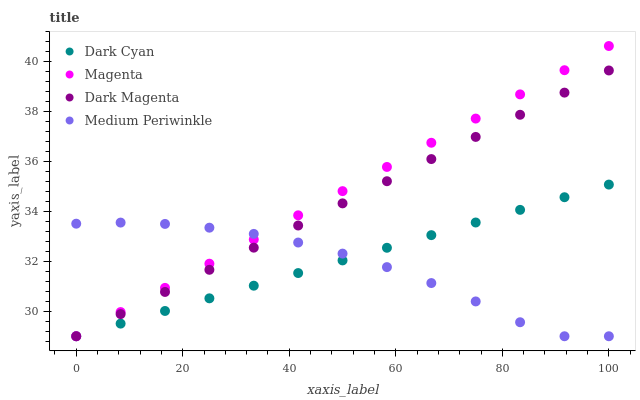Does Medium Periwinkle have the minimum area under the curve?
Answer yes or no. Yes. Does Magenta have the maximum area under the curve?
Answer yes or no. Yes. Does Magenta have the minimum area under the curve?
Answer yes or no. No. Does Medium Periwinkle have the maximum area under the curve?
Answer yes or no. No. Is Dark Cyan the smoothest?
Answer yes or no. Yes. Is Medium Periwinkle the roughest?
Answer yes or no. Yes. Is Magenta the smoothest?
Answer yes or no. No. Is Magenta the roughest?
Answer yes or no. No. Does Dark Cyan have the lowest value?
Answer yes or no. Yes. Does Magenta have the highest value?
Answer yes or no. Yes. Does Medium Periwinkle have the highest value?
Answer yes or no. No. Does Magenta intersect Dark Magenta?
Answer yes or no. Yes. Is Magenta less than Dark Magenta?
Answer yes or no. No. Is Magenta greater than Dark Magenta?
Answer yes or no. No. 